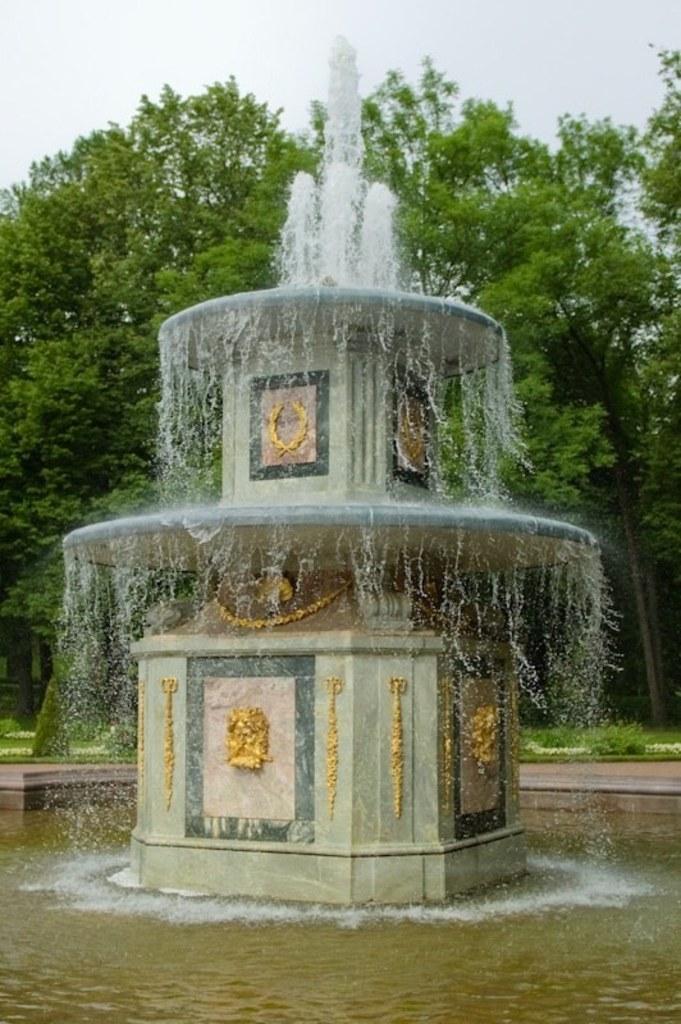Can you describe this image briefly? In this picture I can see the fountain. At the bottom I can see the water. In the back I can see many trees, plants and grass. At the top I can see the sky and clouds. 